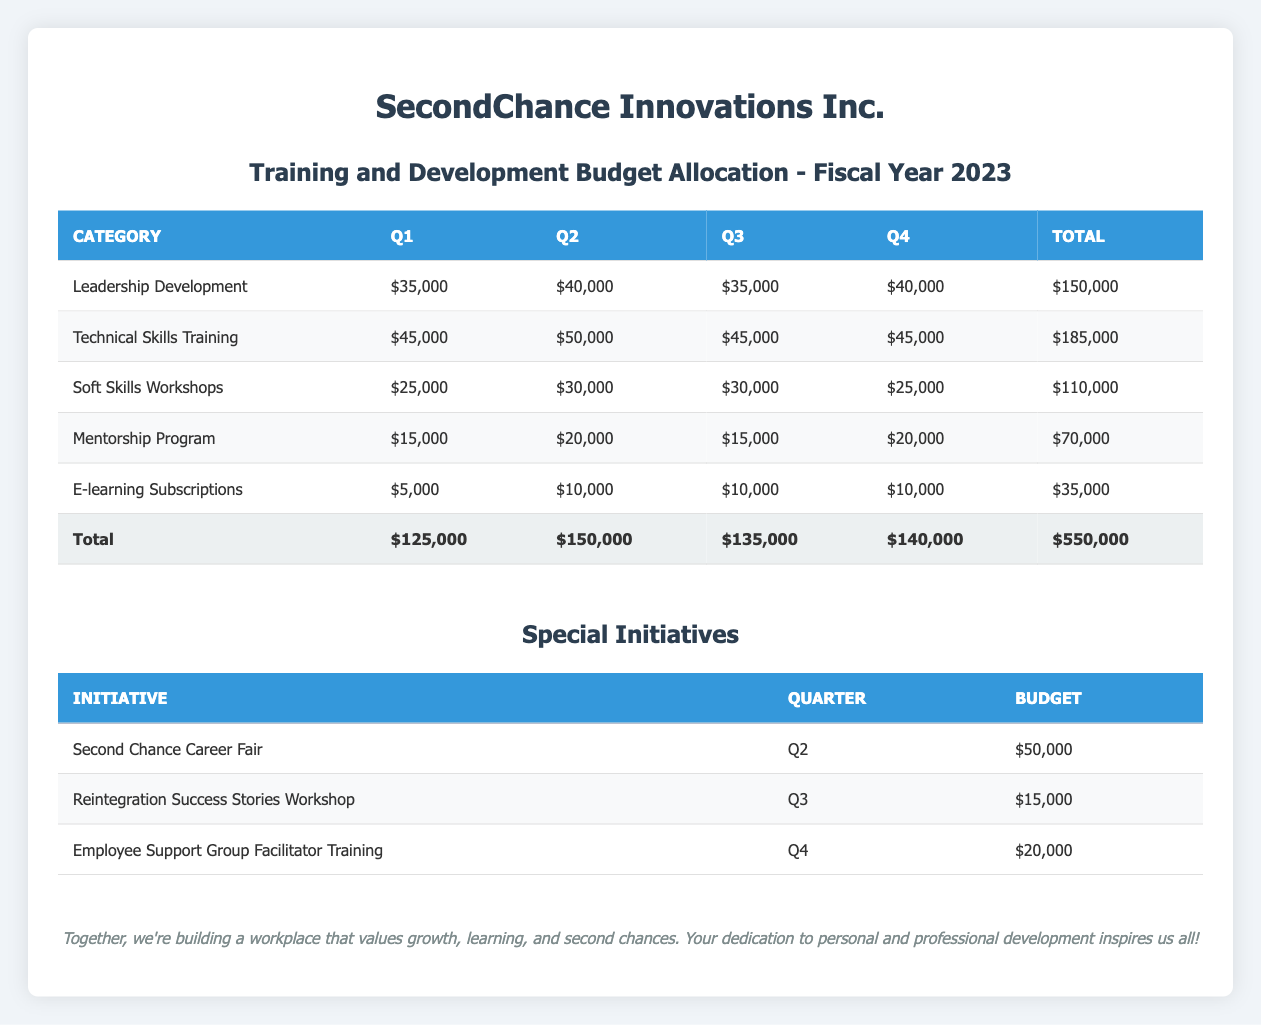What is the total budget for Q3? The total budget for Q3 is listed in the table under the "Total" column for Q3, which shows $135,000.
Answer: 135000 How much is allocated for Technical Skills Training in Q2? The amount allocated for Technical Skills Training in Q2 can be found in the row for this category under the Q2 column, which is $50,000.
Answer: 50000 Which quarter has the highest budget allocation for Leadership Development? The budgets for Leadership Development can be compared across the quarters: Q1 has $35,000, Q2 has $40,000, Q3 has $35,000, and Q4 has $40,000. Q2 and Q4 tie as the quarters with the highest allocation of $40,000.
Answer: Q2 and Q4 What is the total amount allocated across all quarters for Soft Skills Workshops? To find the total for Soft Skills Workshops, we look at the amounts in each quarter: $25,000 (Q1) + $30,000 (Q2) + $30,000 (Q3) + $25,000 (Q4) = $110,000.
Answer: 110000 Is the budget for the Second Chance Career Fair greater than the total budget for E-learning Subscriptions in the entire year? The budget for the Second Chance Career Fair is $50,000, and the total budget for E-learning Subscriptions across all quarters is $35,000 (which is $5,000 + $10,000 + $10,000 + $10,000). Since $50,000 is greater than $35,000, the statement is true.
Answer: Yes How much budget is allocated for special initiatives in Q4? In Q4, the special initiative is the Employee Support Group Facilitator Training, and its budget is $20,000. This can be isolated from the separate table for special initiatives.
Answer: 20000 What is the total budget allocated for all categories in Q1? The total budget for Q1 is already provided at the bottom of the first table, which sums all allocated categories. The total is $125,000.
Answer: 125000 How much is allocated to the Mentorship Program across all quarters? The amounts allocated for the Mentorship Program are $15,000 (Q1) + $20,000 (Q2) + $15,000 (Q3) + $20,000 (Q4) = $70,000.
Answer: 70000 Which category has the least amount allocated in Q2? The categories and their amounts for Q2 are Leadership Development ($40,000), Technical Skills Training ($50,000), Soft Skills Workshops ($30,000), Mentorship Program ($20,000), and E-learning Subscriptions ($10,000). E-learning Subscriptions has the least with $10,000.
Answer: E-learning Subscriptions 